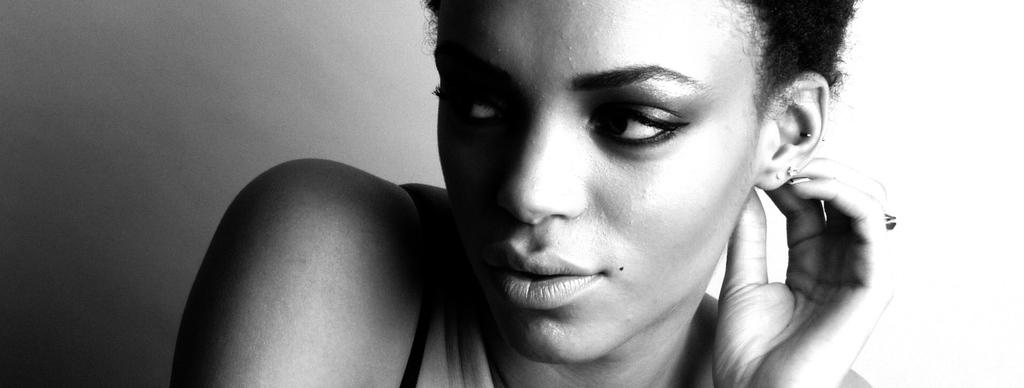What is the main subject of the image? The main subject of the image is a woman. Can you describe the background of the image? The background of the image is white and grey. What type of comfort can be seen in the image? There is no specific type of comfort visible in the image. Is there a woolen item present in the image? There is no woolen item present in the image. Can you see a bat flying in the image? There is no bat visible in the image. 